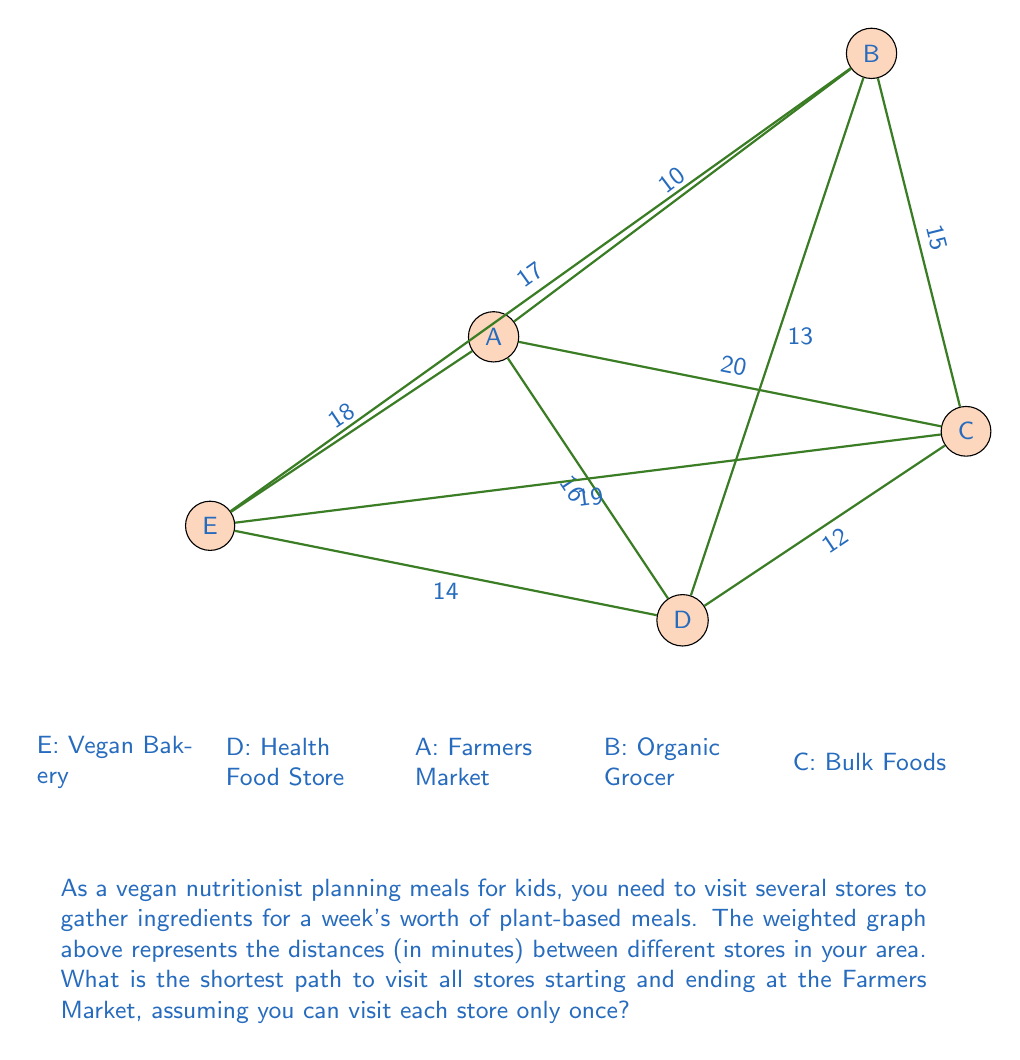Give your solution to this math problem. To solve this problem, we need to find the shortest Hamiltonian cycle in the given weighted graph. This is known as the Traveling Salesman Problem (TSP). For a small graph like this, we can use a brute-force approach to find the optimal solution.

Steps:
1. List all possible cycles starting and ending at A (Farmers Market):
   A-B-C-D-E-A, A-B-C-E-D-A, A-B-D-C-E-A, A-B-D-E-C-A, A-B-E-C-D-A, A-B-E-D-C-A,
   A-C-B-D-E-A, A-C-B-E-D-A, A-C-D-B-E-A, A-C-D-E-B-A, A-C-E-B-D-A, A-C-E-D-B-A,
   A-D-B-C-E-A, A-D-B-E-C-A, A-D-C-B-E-A, A-D-C-E-B-A, A-D-E-B-C-A, A-D-E-C-B-A,
   A-E-B-C-D-A, A-E-B-D-C-A, A-E-C-B-D-A, A-E-C-D-B-A, A-E-D-B-C-A, A-E-D-C-B-A

2. Calculate the total distance for each cycle:
   A-B-C-D-E-A: 10 + 15 + 12 + 14 + 18 = 69
   A-B-C-E-D-A: 10 + 15 + 19 + 14 + 16 = 74
   A-B-D-C-E-A: 10 + 13 + 12 + 19 + 18 = 72
   A-B-D-E-C-A: 10 + 13 + 14 + 19 + 20 = 76
   A-B-E-C-D-A: 10 + 17 + 19 + 12 + 16 = 74
   A-B-E-D-C-A: 10 + 17 + 14 + 12 + 20 = 73
   A-C-B-D-E-A: 20 + 15 + 13 + 14 + 18 = 80
   A-C-B-E-D-A: 20 + 15 + 17 + 14 + 16 = 82
   A-C-D-B-E-A: 20 + 12 + 13 + 17 + 18 = 80
   A-C-D-E-B-A: 20 + 12 + 14 + 17 + 10 = 73
   A-C-E-B-D-A: 20 + 19 + 17 + 13 + 16 = 85
   A-C-E-D-B-A: 20 + 19 + 14 + 13 + 10 = 76
   A-D-B-C-E-A: 16 + 13 + 15 + 19 + 18 = 81
   A-D-B-E-C-A: 16 + 13 + 17 + 19 + 20 = 85
   A-D-C-B-E-A: 16 + 12 + 15 + 17 + 18 = 78
   A-D-C-E-B-A: 16 + 12 + 19 + 17 + 10 = 74
   A-D-E-B-C-A: 16 + 14 + 17 + 15 + 20 = 82
   A-D-E-C-B-A: 16 + 14 + 19 + 15 + 10 = 74
   A-E-B-C-D-A: 18 + 17 + 15 + 12 + 16 = 78
   A-E-B-D-C-A: 18 + 17 + 13 + 12 + 20 = 80
   A-E-C-B-D-A: 18 + 19 + 15 + 13 + 16 = 81
   A-E-C-D-B-A: 18 + 19 + 12 + 13 + 10 = 72
   A-E-D-B-C-A: 18 + 14 + 13 + 15 + 20 = 80
   A-E-D-C-B-A: 18 + 14 + 12 + 15 + 10 = 69

3. Identify the shortest path(s):
   There are two paths with the minimum distance of 69 minutes:
   A-B-C-D-E-A and A-E-D-C-B-A

Therefore, the shortest path to visit all stores starting and ending at the Farmers Market is either A-B-C-D-E-A or A-E-D-C-B-A, both with a total distance of 69 minutes.
Answer: A-B-C-D-E-A or A-E-D-C-B-A, 69 minutes 